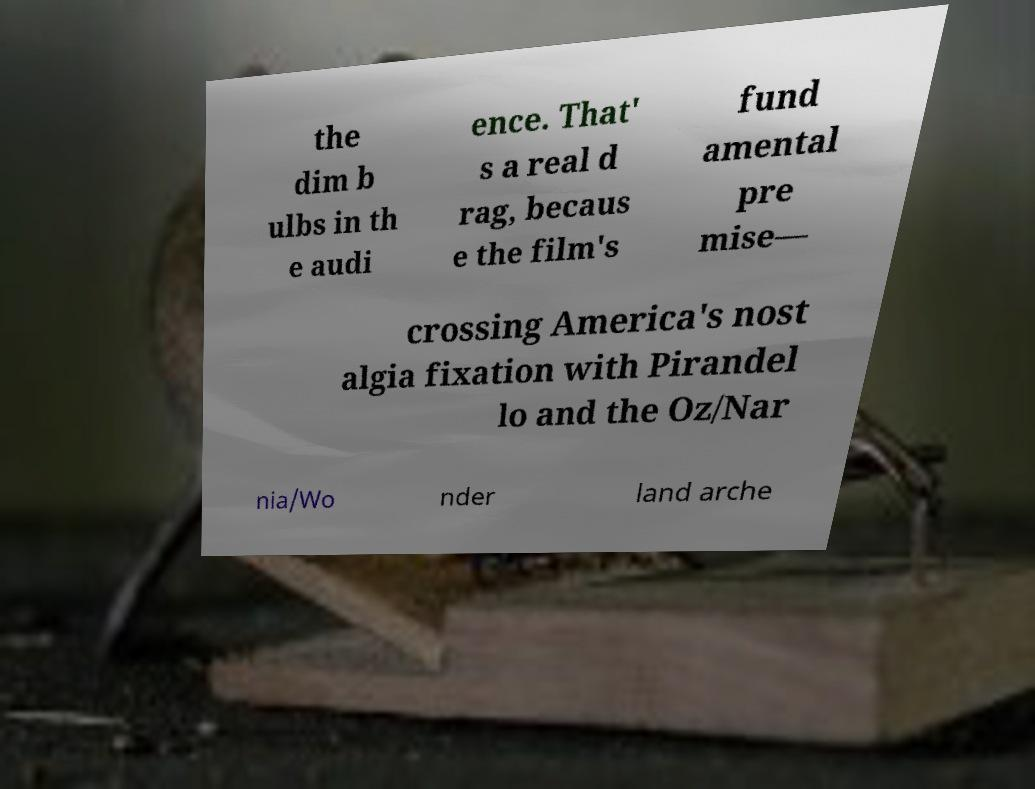Could you assist in decoding the text presented in this image and type it out clearly? the dim b ulbs in th e audi ence. That' s a real d rag, becaus e the film's fund amental pre mise— crossing America's nost algia fixation with Pirandel lo and the Oz/Nar nia/Wo nder land arche 